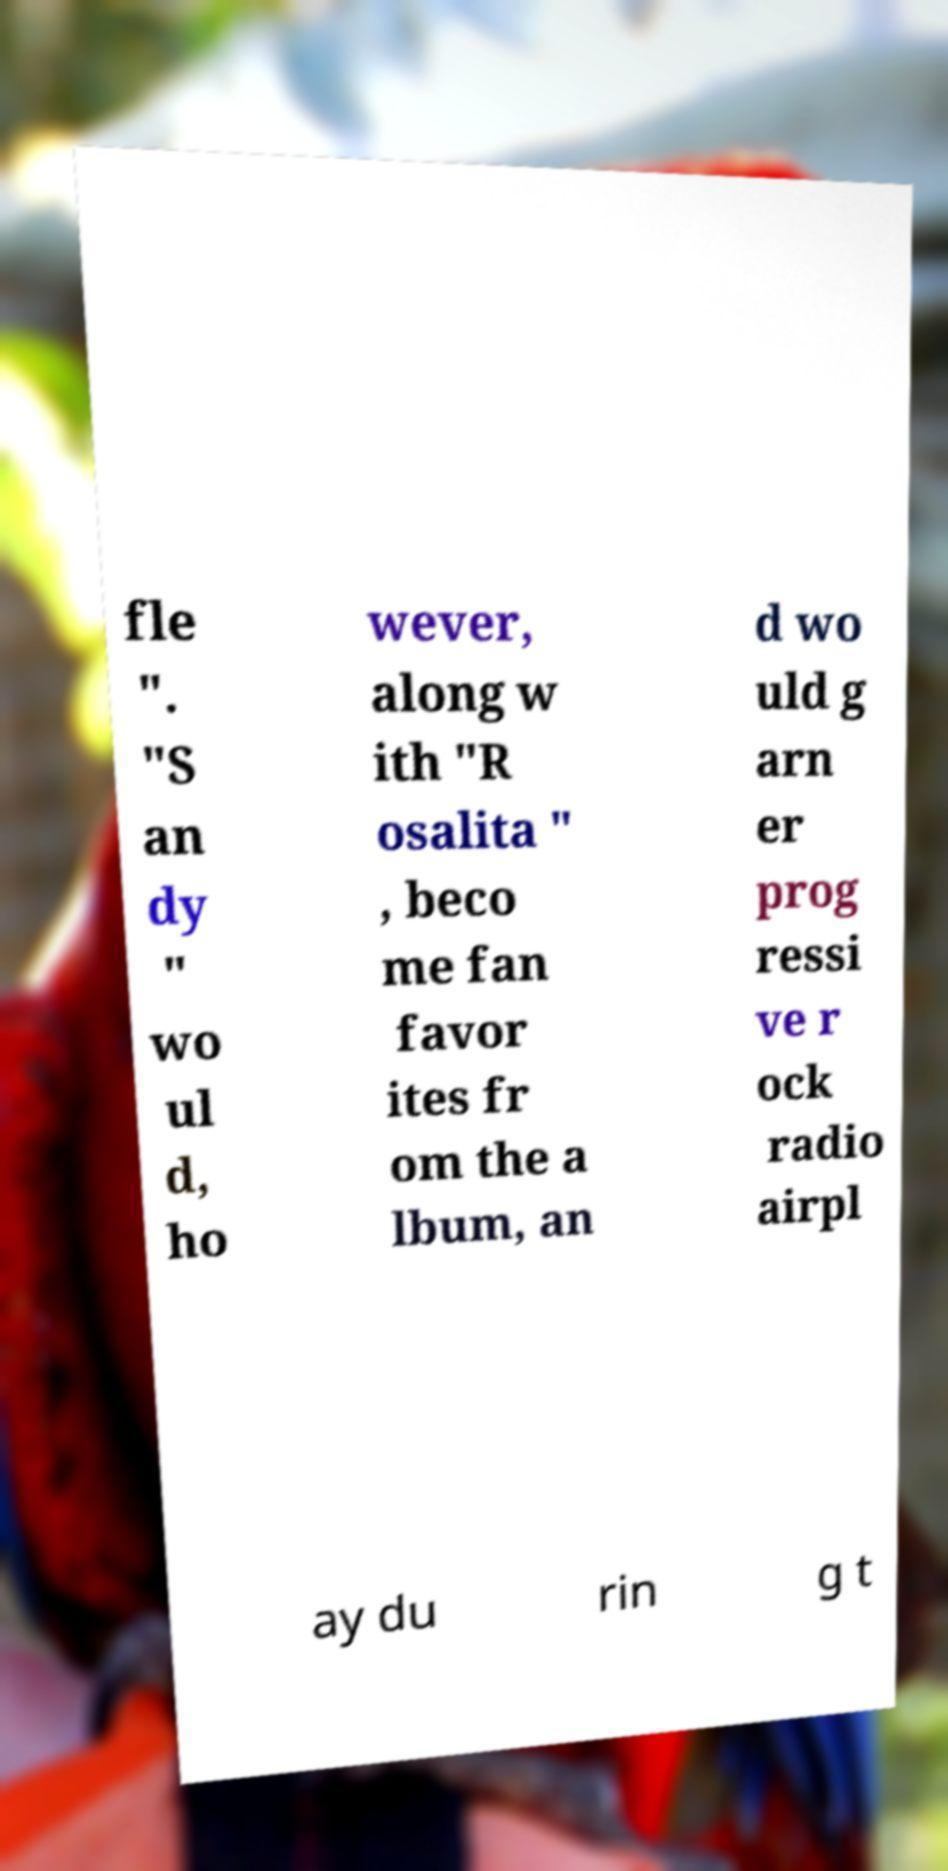I need the written content from this picture converted into text. Can you do that? fle ". "S an dy " wo ul d, ho wever, along w ith "R osalita " , beco me fan favor ites fr om the a lbum, an d wo uld g arn er prog ressi ve r ock radio airpl ay du rin g t 